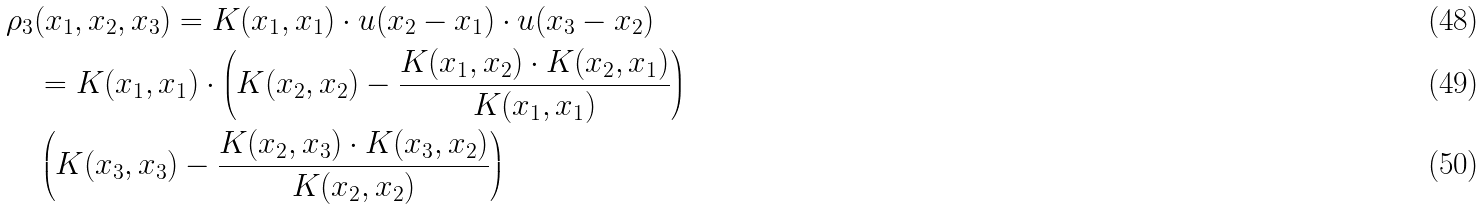<formula> <loc_0><loc_0><loc_500><loc_500>& \rho _ { 3 } ( x _ { 1 } , x _ { 2 } , x _ { 3 } ) = K ( x _ { 1 } , x _ { 1 } ) \cdot u ( x _ { 2 } - x _ { 1 } ) \cdot u ( x _ { 3 } - x _ { 2 } ) \\ & \quad = K ( x _ { 1 } , x _ { 1 } ) \cdot \left ( K ( x _ { 2 } , x _ { 2 } ) - \frac { K ( x _ { 1 } , x _ { 2 } ) \cdot K ( x _ { 2 } , x _ { 1 } ) } { K ( x _ { 1 } , x _ { 1 } ) } \right ) \\ & \quad \left ( K ( x _ { 3 } , x _ { 3 } ) - \frac { K ( x _ { 2 } , x _ { 3 } ) \cdot K ( x _ { 3 } , x _ { 2 } ) } { K ( x _ { 2 } , x _ { 2 } ) } \right )</formula> 